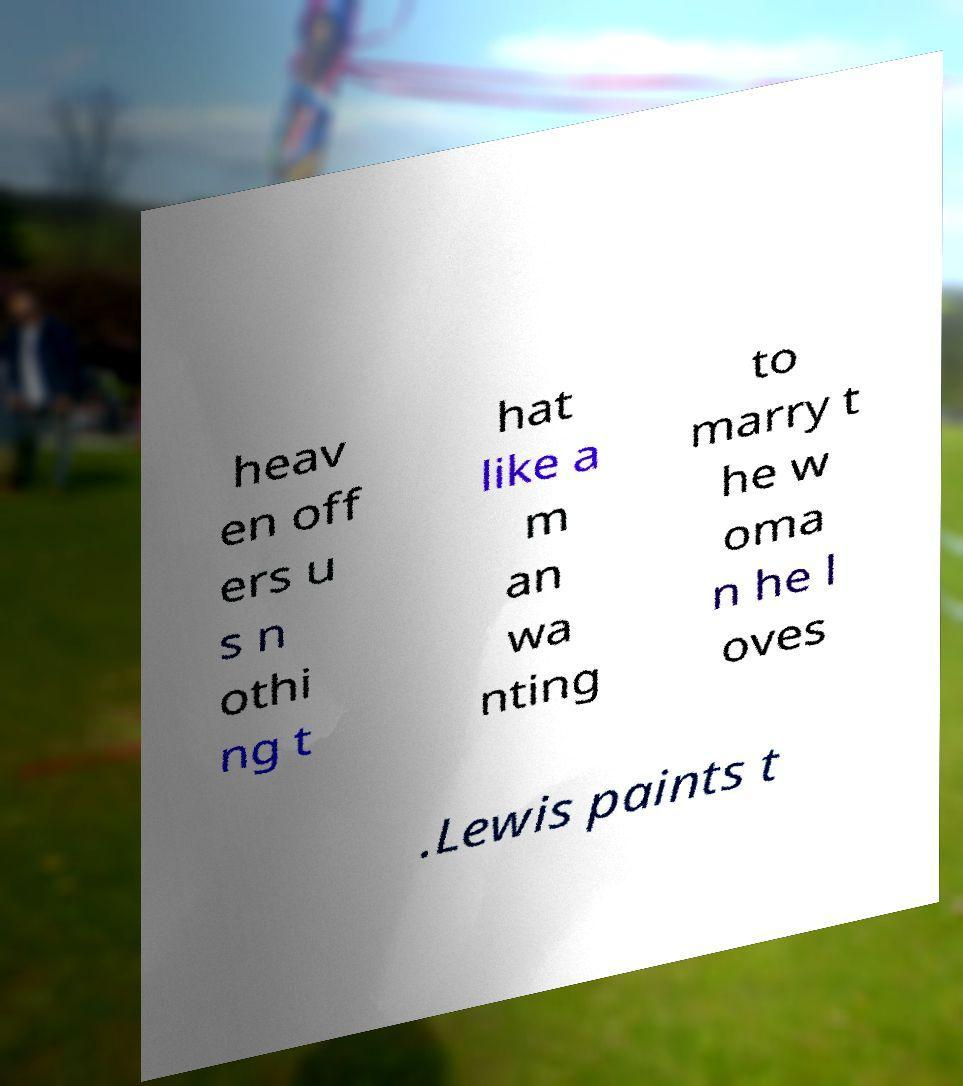I need the written content from this picture converted into text. Can you do that? heav en off ers u s n othi ng t hat like a m an wa nting to marry t he w oma n he l oves .Lewis paints t 